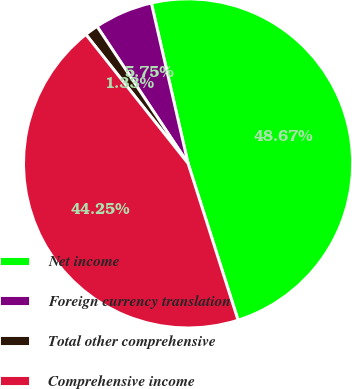<chart> <loc_0><loc_0><loc_500><loc_500><pie_chart><fcel>Net income<fcel>Foreign currency translation<fcel>Total other comprehensive<fcel>Comprehensive income<nl><fcel>48.67%<fcel>5.75%<fcel>1.33%<fcel>44.25%<nl></chart> 